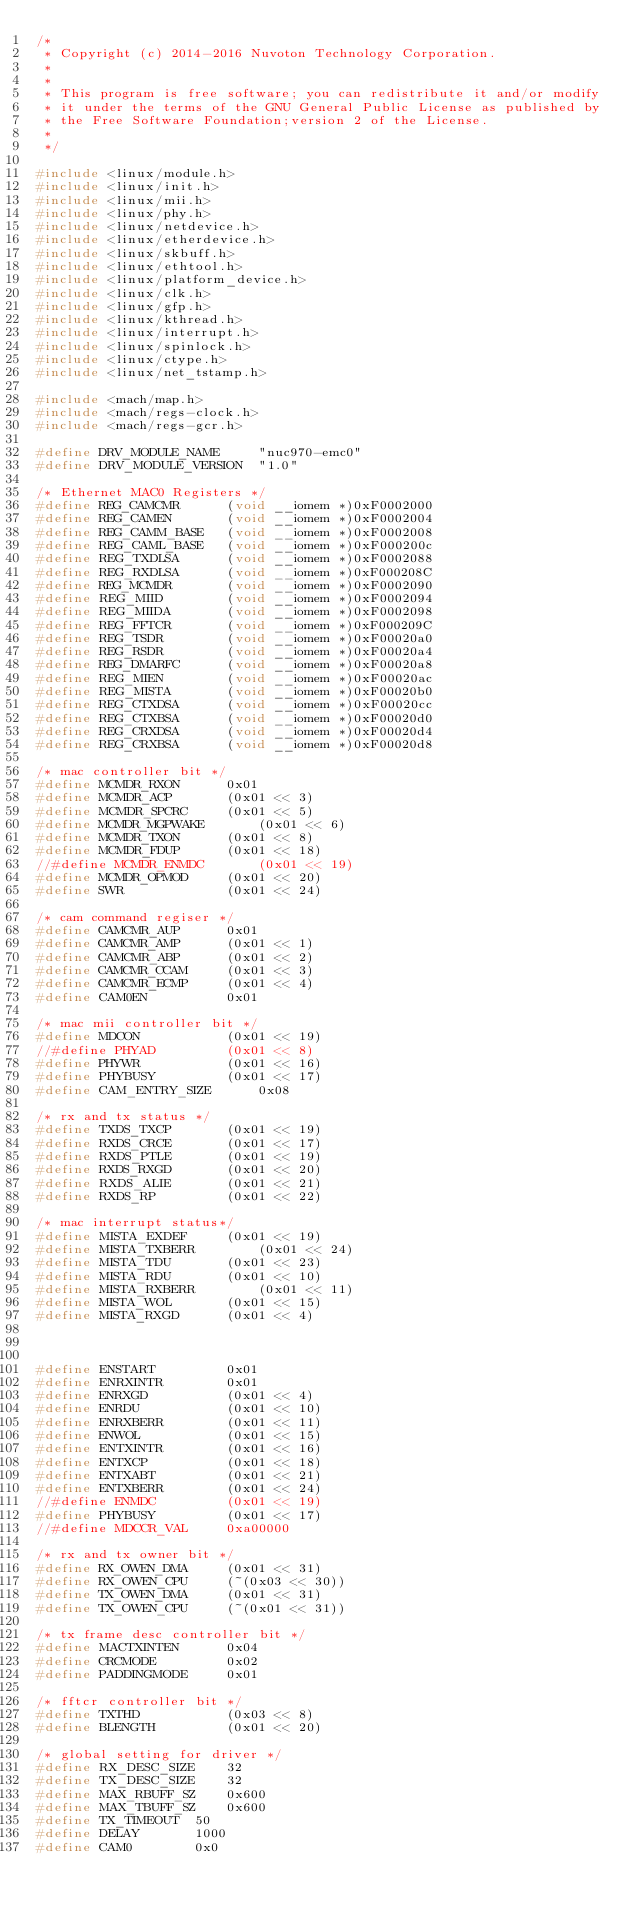Convert code to text. <code><loc_0><loc_0><loc_500><loc_500><_C_>/*
 * Copyright (c) 2014-2016 Nuvoton Technology Corporation.
 *
 *
 * This program is free software; you can redistribute it and/or modify
 * it under the terms of the GNU General Public License as published by
 * the Free Software Foundation;version 2 of the License.
 *
 */

#include <linux/module.h>
#include <linux/init.h>
#include <linux/mii.h>
#include <linux/phy.h>
#include <linux/netdevice.h>
#include <linux/etherdevice.h>
#include <linux/skbuff.h>
#include <linux/ethtool.h>
#include <linux/platform_device.h>
#include <linux/clk.h>
#include <linux/gfp.h>
#include <linux/kthread.h>
#include <linux/interrupt.h>
#include <linux/spinlock.h>
#include <linux/ctype.h>
#include <linux/net_tstamp.h>

#include <mach/map.h>
#include <mach/regs-clock.h>
#include <mach/regs-gcr.h>

#define DRV_MODULE_NAME		"nuc970-emc0"
#define DRV_MODULE_VERSION	"1.0"

/* Ethernet MAC0 Registers */
#define REG_CAMCMR		(void __iomem *)0xF0002000
#define REG_CAMEN		(void __iomem *)0xF0002004
#define REG_CAMM_BASE	(void __iomem *)0xF0002008
#define REG_CAML_BASE	(void __iomem *)0xF000200c
#define REG_TXDLSA		(void __iomem *)0xF0002088
#define REG_RXDLSA		(void __iomem *)0xF000208C
#define REG_MCMDR		(void __iomem *)0xF0002090
#define REG_MIID		(void __iomem *)0xF0002094
#define REG_MIIDA		(void __iomem *)0xF0002098
#define REG_FFTCR		(void __iomem *)0xF000209C
#define REG_TSDR		(void __iomem *)0xF00020a0
#define REG_RSDR		(void __iomem *)0xF00020a4
#define REG_DMARFC		(void __iomem *)0xF00020a8
#define REG_MIEN		(void __iomem *)0xF00020ac
#define REG_MISTA		(void __iomem *)0xF00020b0
#define REG_CTXDSA		(void __iomem *)0xF00020cc
#define REG_CTXBSA		(void __iomem *)0xF00020d0
#define REG_CRXDSA		(void __iomem *)0xF00020d4
#define REG_CRXBSA		(void __iomem *)0xF00020d8

/* mac controller bit */
#define MCMDR_RXON		0x01
#define MCMDR_ACP		(0x01 << 3)
#define MCMDR_SPCRC		(0x01 << 5)
#define MCMDR_MGPWAKE		(0x01 << 6)
#define MCMDR_TXON		(0x01 << 8)
#define MCMDR_FDUP		(0x01 << 18)
//#define MCMDR_ENMDC		(0x01 << 19)
#define MCMDR_OPMOD		(0x01 << 20)
#define SWR				(0x01 << 24)

/* cam command regiser */
#define CAMCMR_AUP		0x01
#define CAMCMR_AMP		(0x01 << 1)
#define CAMCMR_ABP		(0x01 << 2)
#define CAMCMR_CCAM		(0x01 << 3)
#define CAMCMR_ECMP		(0x01 << 4)
#define CAM0EN			0x01

/* mac mii controller bit */
#define MDCON			(0x01 << 19)
//#define PHYAD			(0x01 << 8)
#define PHYWR			(0x01 << 16)
#define PHYBUSY			(0x01 << 17)
#define CAM_ENTRY_SIZE		0x08

/* rx and tx status */
#define TXDS_TXCP		(0x01 << 19)
#define RXDS_CRCE		(0x01 << 17)
#define RXDS_PTLE		(0x01 << 19)
#define RXDS_RXGD		(0x01 << 20)
#define RXDS_ALIE		(0x01 << 21)
#define RXDS_RP			(0x01 << 22)

/* mac interrupt status*/
#define MISTA_EXDEF		(0x01 << 19)
#define MISTA_TXBERR		(0x01 << 24)
#define MISTA_TDU		(0x01 << 23)
#define MISTA_RDU		(0x01 << 10)
#define MISTA_RXBERR		(0x01 << 11)
#define MISTA_WOL		(0x01 << 15)
#define MISTA_RXGD		(0x01 << 4)



#define ENSTART			0x01
#define ENRXINTR		0x01
#define ENRXGD			(0x01 << 4)
#define ENRDU			(0x01 << 10)
#define ENRXBERR		(0x01 << 11)
#define ENWOL			(0x01 << 15)
#define ENTXINTR		(0x01 << 16)
#define ENTXCP			(0x01 << 18)
#define ENTXABT			(0x01 << 21)
#define ENTXBERR		(0x01 << 24)
//#define ENMDC			(0x01 << 19)
#define PHYBUSY			(0x01 << 17)
//#define MDCCR_VAL		0xa00000

/* rx and tx owner bit */
#define RX_OWEN_DMA		(0x01 << 31)
#define RX_OWEN_CPU		(~(0x03 << 30))
#define TX_OWEN_DMA		(0x01 << 31)
#define TX_OWEN_CPU		(~(0x01 << 31))

/* tx frame desc controller bit */
#define MACTXINTEN		0x04
#define CRCMODE			0x02
#define PADDINGMODE		0x01

/* fftcr controller bit */
#define TXTHD 			(0x03 << 8)
#define BLENGTH			(0x01 << 20)

/* global setting for driver */
#define RX_DESC_SIZE	32
#define TX_DESC_SIZE	32
#define MAX_RBUFF_SZ	0x600
#define MAX_TBUFF_SZ	0x600
#define TX_TIMEOUT	50
#define DELAY		1000
#define CAM0		0x0
</code> 